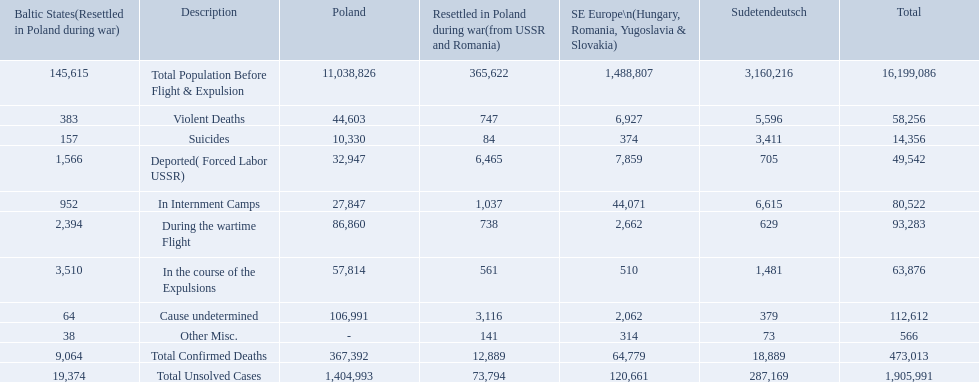How many total confirmed deaths were there in the baltic states? 9,064. How many deaths had an undetermined cause? 64. How many deaths in that region were miscellaneous? 38. Were there more deaths from an undetermined cause or that were listed as miscellaneous? Cause undetermined. 